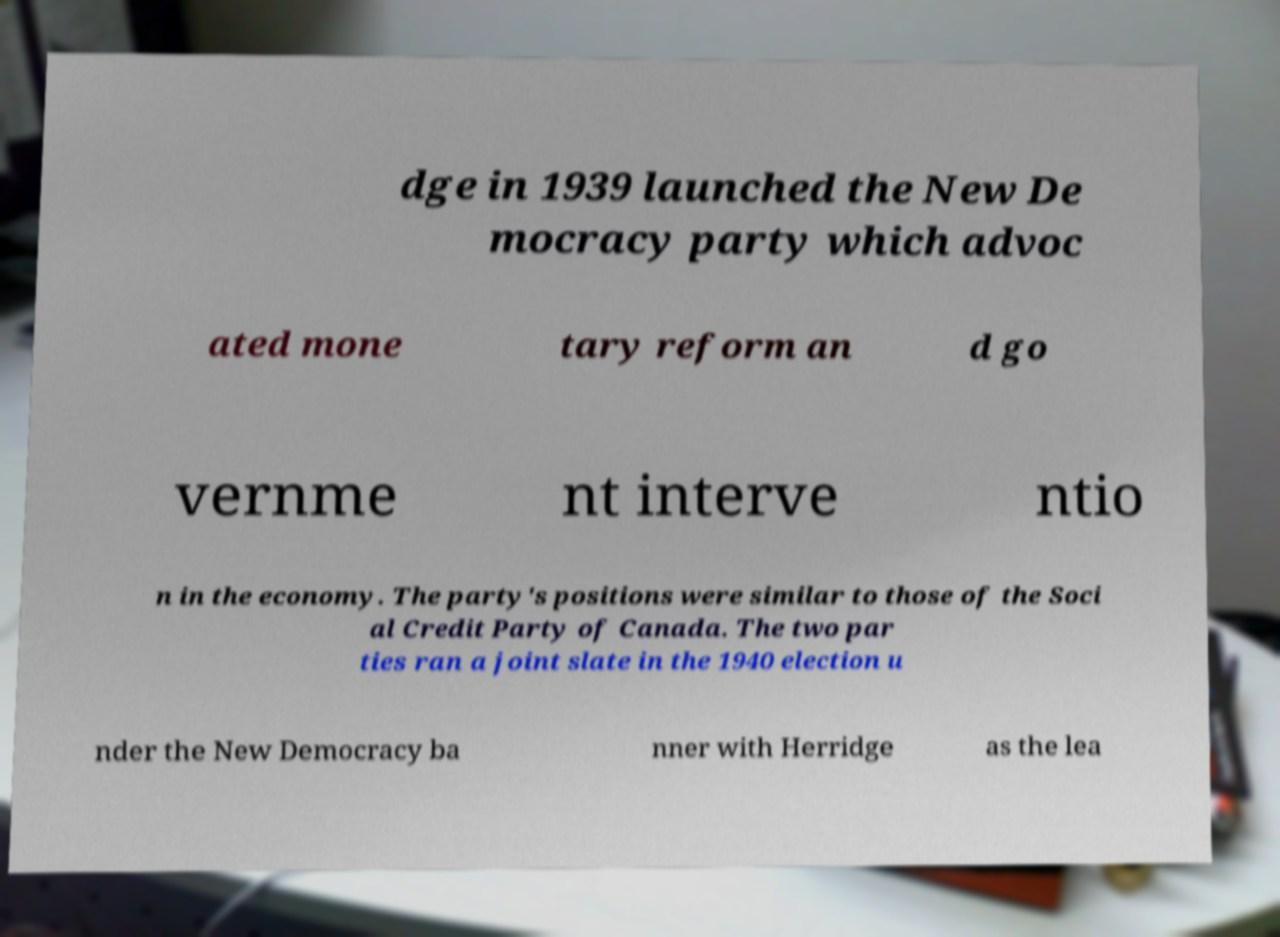There's text embedded in this image that I need extracted. Can you transcribe it verbatim? dge in 1939 launched the New De mocracy party which advoc ated mone tary reform an d go vernme nt interve ntio n in the economy. The party's positions were similar to those of the Soci al Credit Party of Canada. The two par ties ran a joint slate in the 1940 election u nder the New Democracy ba nner with Herridge as the lea 